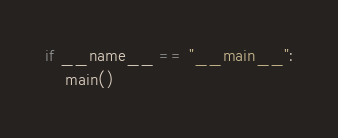<code> <loc_0><loc_0><loc_500><loc_500><_Python_>
if __name__ == "__main__":
    main()
</code> 